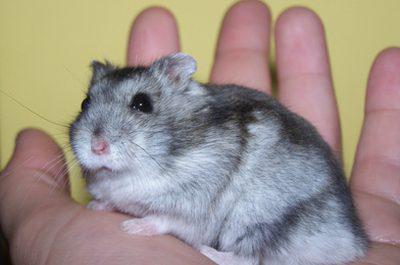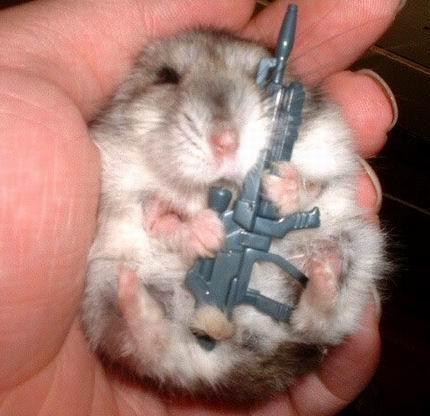The first image is the image on the left, the second image is the image on the right. For the images shown, is this caption "A human hand is holding a hamster in at least one of the images." true? Answer yes or no. Yes. 